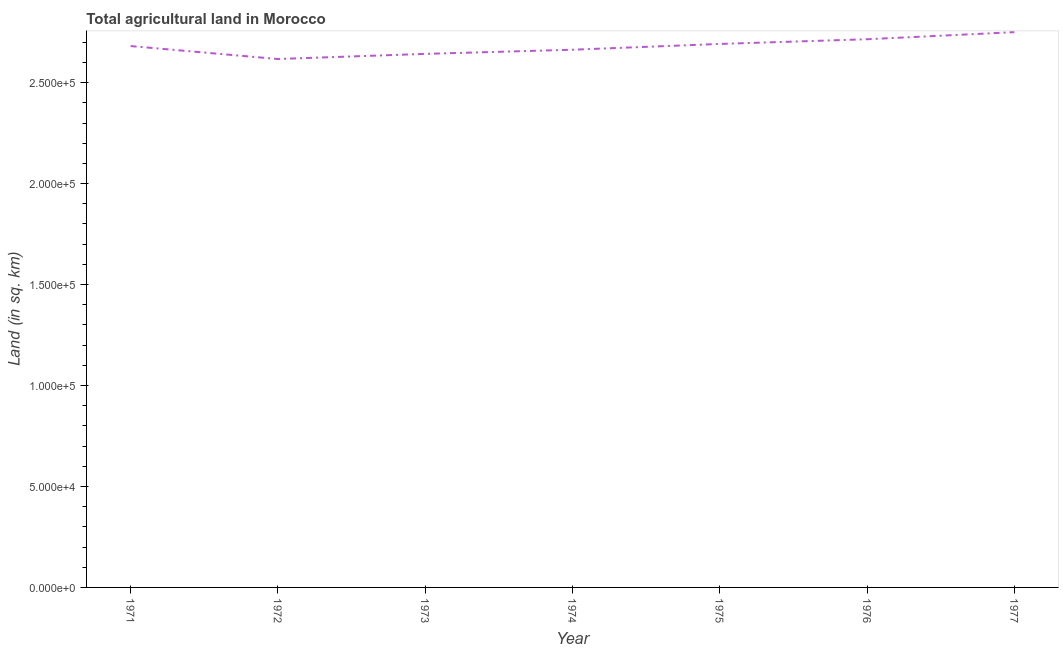What is the agricultural land in 1975?
Your response must be concise. 2.69e+05. Across all years, what is the maximum agricultural land?
Give a very brief answer. 2.75e+05. Across all years, what is the minimum agricultural land?
Ensure brevity in your answer.  2.62e+05. In which year was the agricultural land maximum?
Provide a short and direct response. 1977. In which year was the agricultural land minimum?
Offer a very short reply. 1972. What is the sum of the agricultural land?
Offer a terse response. 1.88e+06. What is the difference between the agricultural land in 1972 and 1975?
Your answer should be compact. -7470. What is the average agricultural land per year?
Keep it short and to the point. 2.68e+05. What is the median agricultural land?
Provide a short and direct response. 2.68e+05. In how many years, is the agricultural land greater than 70000 sq. km?
Keep it short and to the point. 7. What is the ratio of the agricultural land in 1971 to that in 1973?
Ensure brevity in your answer.  1.01. Is the agricultural land in 1974 less than that in 1976?
Your response must be concise. Yes. Is the difference between the agricultural land in 1971 and 1977 greater than the difference between any two years?
Your answer should be very brief. No. What is the difference between the highest and the second highest agricultural land?
Your answer should be compact. 3500. Is the sum of the agricultural land in 1976 and 1977 greater than the maximum agricultural land across all years?
Your response must be concise. Yes. What is the difference between the highest and the lowest agricultural land?
Make the answer very short. 1.33e+04. Does the agricultural land monotonically increase over the years?
Offer a terse response. No. How many lines are there?
Keep it short and to the point. 1. How many years are there in the graph?
Ensure brevity in your answer.  7. Are the values on the major ticks of Y-axis written in scientific E-notation?
Your response must be concise. Yes. Does the graph contain grids?
Ensure brevity in your answer.  No. What is the title of the graph?
Your response must be concise. Total agricultural land in Morocco. What is the label or title of the X-axis?
Keep it short and to the point. Year. What is the label or title of the Y-axis?
Provide a succinct answer. Land (in sq. km). What is the Land (in sq. km) of 1971?
Your answer should be very brief. 2.68e+05. What is the Land (in sq. km) in 1972?
Your response must be concise. 2.62e+05. What is the Land (in sq. km) of 1973?
Your answer should be very brief. 2.64e+05. What is the Land (in sq. km) of 1974?
Your answer should be compact. 2.66e+05. What is the Land (in sq. km) of 1975?
Give a very brief answer. 2.69e+05. What is the Land (in sq. km) of 1976?
Your answer should be very brief. 2.72e+05. What is the Land (in sq. km) of 1977?
Your answer should be compact. 2.75e+05. What is the difference between the Land (in sq. km) in 1971 and 1972?
Your response must be concise. 6420. What is the difference between the Land (in sq. km) in 1971 and 1973?
Offer a very short reply. 3870. What is the difference between the Land (in sq. km) in 1971 and 1974?
Make the answer very short. 1820. What is the difference between the Land (in sq. km) in 1971 and 1975?
Offer a terse response. -1050. What is the difference between the Land (in sq. km) in 1971 and 1976?
Ensure brevity in your answer.  -3380. What is the difference between the Land (in sq. km) in 1971 and 1977?
Offer a terse response. -6880. What is the difference between the Land (in sq. km) in 1972 and 1973?
Provide a short and direct response. -2550. What is the difference between the Land (in sq. km) in 1972 and 1974?
Offer a terse response. -4600. What is the difference between the Land (in sq. km) in 1972 and 1975?
Provide a succinct answer. -7470. What is the difference between the Land (in sq. km) in 1972 and 1976?
Your response must be concise. -9800. What is the difference between the Land (in sq. km) in 1972 and 1977?
Ensure brevity in your answer.  -1.33e+04. What is the difference between the Land (in sq. km) in 1973 and 1974?
Provide a succinct answer. -2050. What is the difference between the Land (in sq. km) in 1973 and 1975?
Your answer should be compact. -4920. What is the difference between the Land (in sq. km) in 1973 and 1976?
Offer a very short reply. -7250. What is the difference between the Land (in sq. km) in 1973 and 1977?
Your answer should be compact. -1.08e+04. What is the difference between the Land (in sq. km) in 1974 and 1975?
Provide a short and direct response. -2870. What is the difference between the Land (in sq. km) in 1974 and 1976?
Offer a terse response. -5200. What is the difference between the Land (in sq. km) in 1974 and 1977?
Give a very brief answer. -8700. What is the difference between the Land (in sq. km) in 1975 and 1976?
Offer a terse response. -2330. What is the difference between the Land (in sq. km) in 1975 and 1977?
Make the answer very short. -5830. What is the difference between the Land (in sq. km) in 1976 and 1977?
Your answer should be very brief. -3500. What is the ratio of the Land (in sq. km) in 1971 to that in 1972?
Your answer should be compact. 1.02. What is the ratio of the Land (in sq. km) in 1971 to that in 1973?
Give a very brief answer. 1.01. What is the ratio of the Land (in sq. km) in 1971 to that in 1976?
Provide a short and direct response. 0.99. What is the ratio of the Land (in sq. km) in 1972 to that in 1974?
Keep it short and to the point. 0.98. What is the ratio of the Land (in sq. km) in 1972 to that in 1975?
Ensure brevity in your answer.  0.97. What is the ratio of the Land (in sq. km) in 1972 to that in 1977?
Your answer should be compact. 0.95. What is the ratio of the Land (in sq. km) in 1973 to that in 1974?
Offer a terse response. 0.99. What is the ratio of the Land (in sq. km) in 1973 to that in 1975?
Give a very brief answer. 0.98. What is the ratio of the Land (in sq. km) in 1974 to that in 1977?
Give a very brief answer. 0.97. What is the ratio of the Land (in sq. km) in 1975 to that in 1976?
Your response must be concise. 0.99. What is the ratio of the Land (in sq. km) in 1976 to that in 1977?
Give a very brief answer. 0.99. 